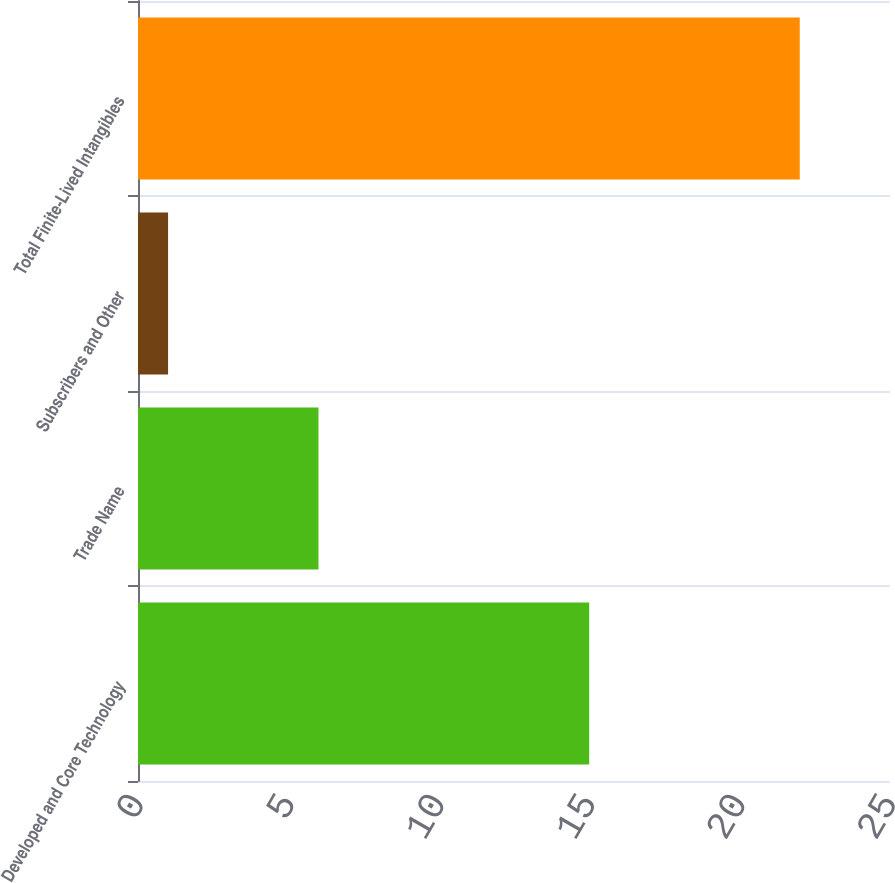<chart> <loc_0><loc_0><loc_500><loc_500><bar_chart><fcel>Developed and Core Technology<fcel>Trade Name<fcel>Subscribers and Other<fcel>Total Finite-Lived Intangibles<nl><fcel>15<fcel>6<fcel>1<fcel>22<nl></chart> 